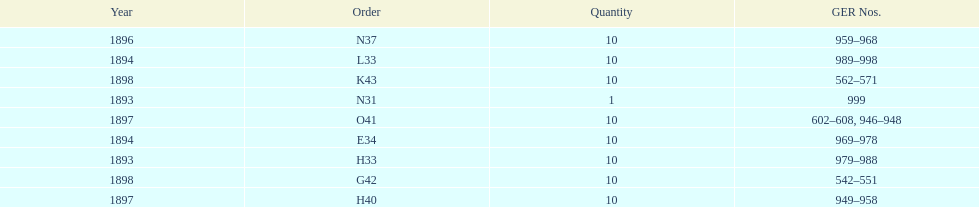What order is listed first at the top of the table? N31. 